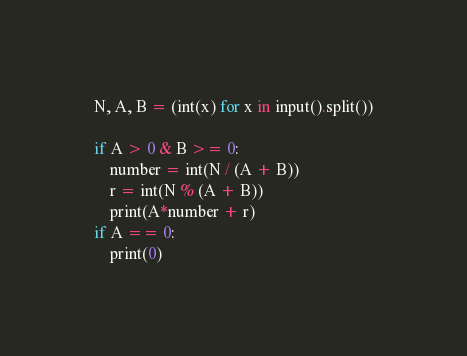<code> <loc_0><loc_0><loc_500><loc_500><_Python_>N, A, B = (int(x) for x in input().split())

if A > 0 & B >= 0:
    number = int(N / (A + B))
    r = int(N % (A + B))
    print(A*number + r)
if A == 0:
    print(0)
</code> 